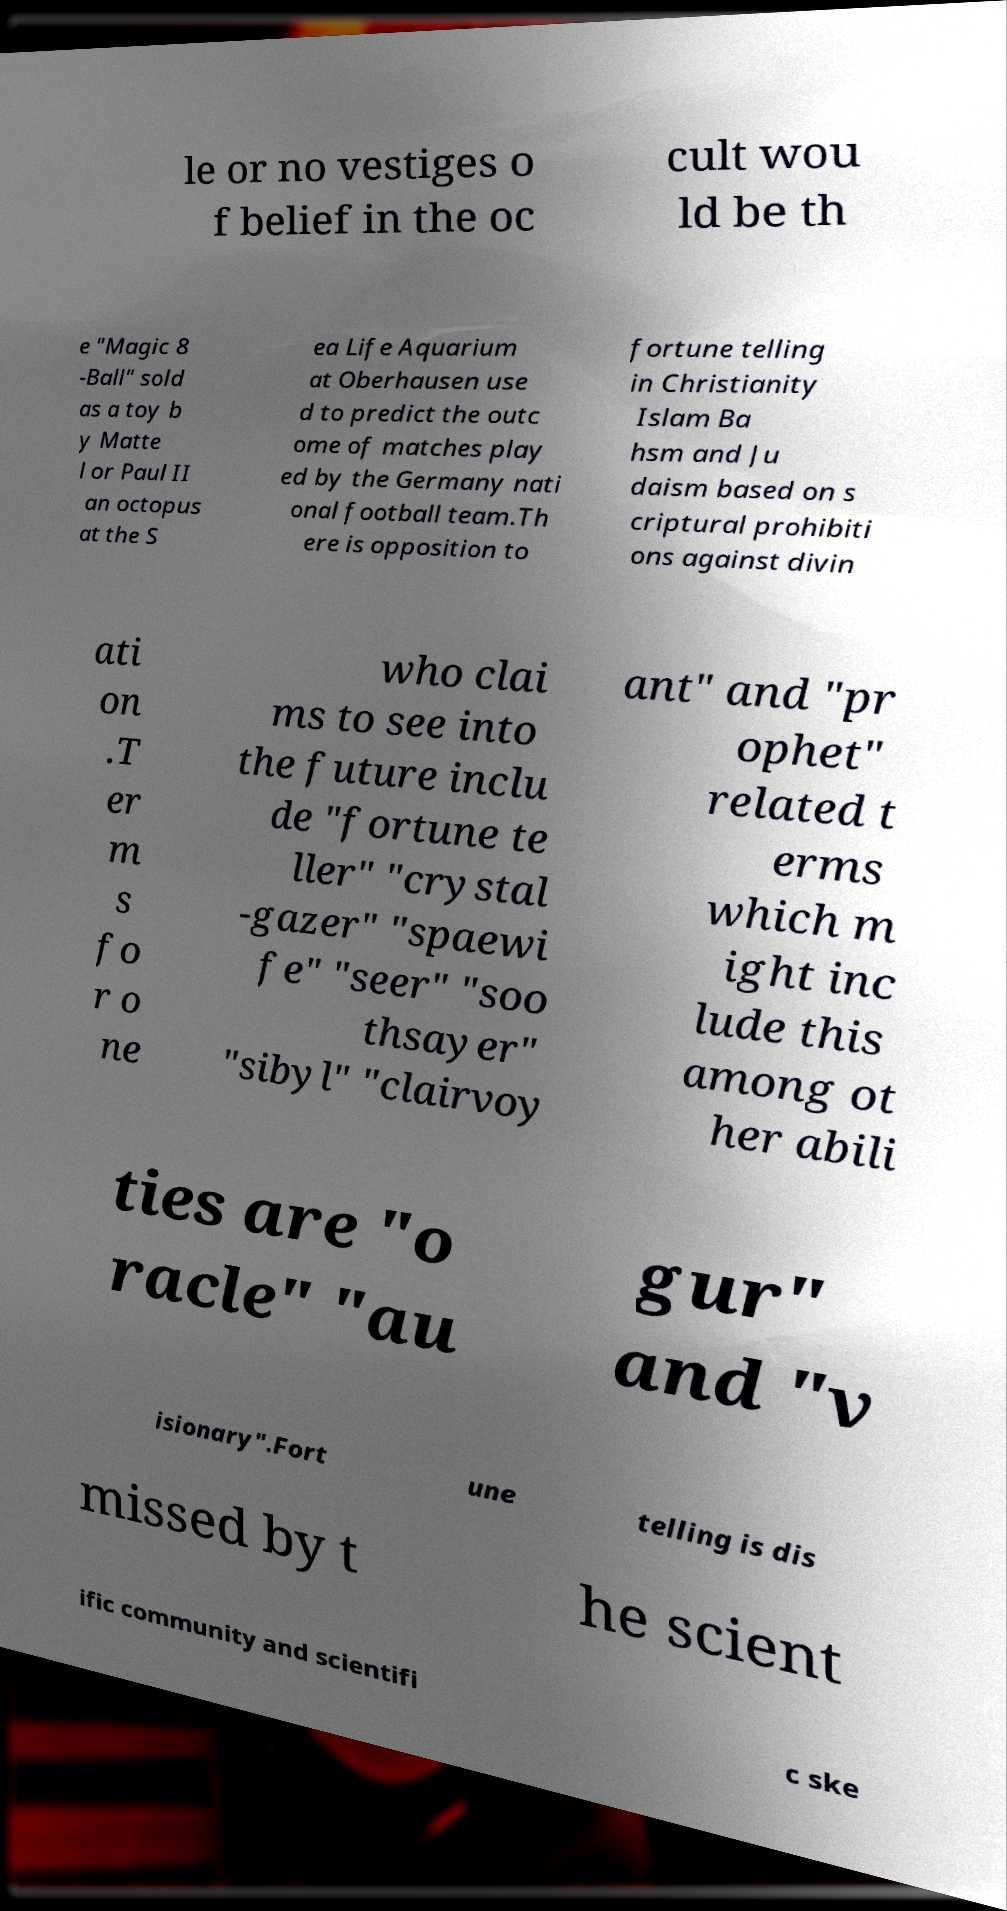Could you extract and type out the text from this image? le or no vestiges o f belief in the oc cult wou ld be th e "Magic 8 -Ball" sold as a toy b y Matte l or Paul II an octopus at the S ea Life Aquarium at Oberhausen use d to predict the outc ome of matches play ed by the Germany nati onal football team.Th ere is opposition to fortune telling in Christianity Islam Ba hsm and Ju daism based on s criptural prohibiti ons against divin ati on .T er m s fo r o ne who clai ms to see into the future inclu de "fortune te ller" "crystal -gazer" "spaewi fe" "seer" "soo thsayer" "sibyl" "clairvoy ant" and "pr ophet" related t erms which m ight inc lude this among ot her abili ties are "o racle" "au gur" and "v isionary".Fort une telling is dis missed by t he scient ific community and scientifi c ske 